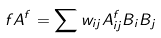Convert formula to latex. <formula><loc_0><loc_0><loc_500><loc_500>\ f A ^ { f } = \sum w _ { i j } A ^ { f } _ { i j } B _ { i } B _ { j }</formula> 